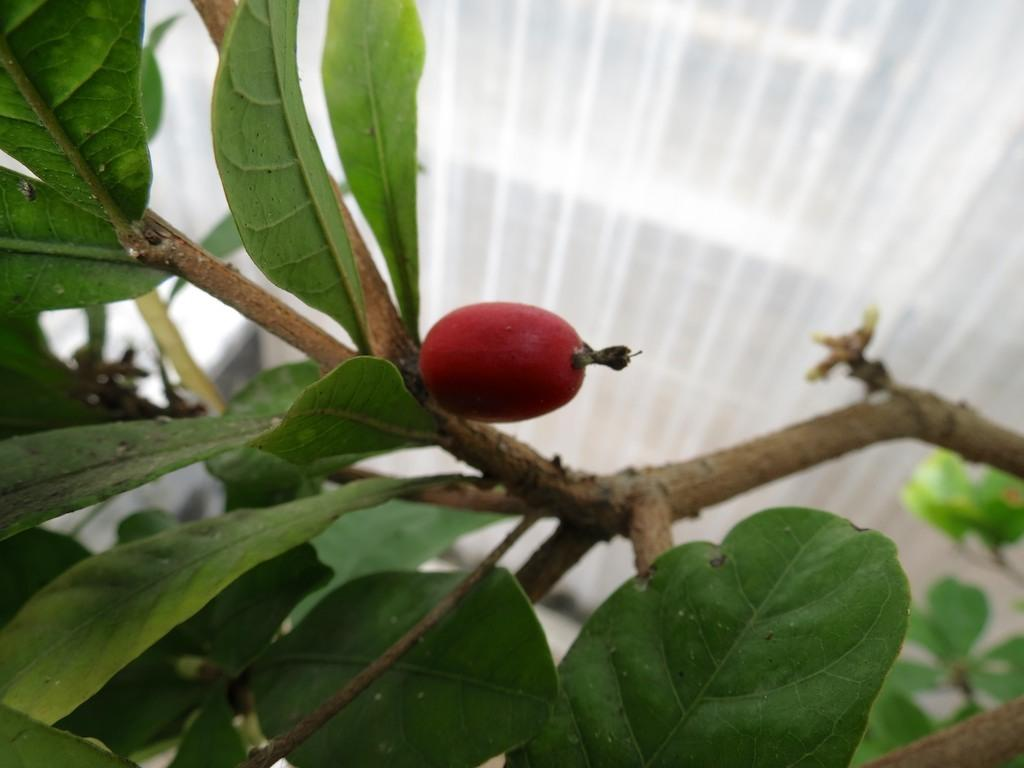What type of fruit can be seen in the image? There is a fruit on a tree in the image. What structure is visible in the image? There is a roof visible in the image. What type of teaching is being conducted in the image? There is no teaching or educational activity depicted in the image. Can you recite the verse that is being spoken in the image? There is no verse or spoken content present in the image. 